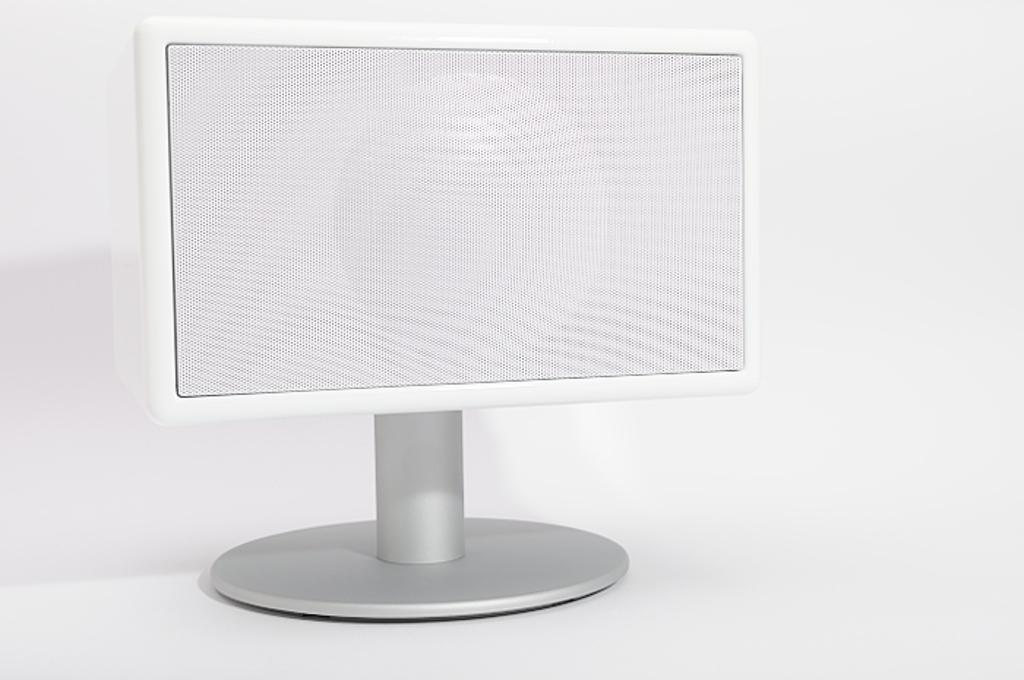What type of electronic device is present in the image? There is a white color monitor in the image. What color is the monitor in the image? The monitor in the image is white. What can be observed about the background of the image? The background of the image is white. What type of jewel is placed on the monitor in the image? There is no jewel present on the monitor in the image. What is the source of power for the monitor in the image? The source of power for the monitor is not visible in the image, but it typically requires a power cord or battery. 